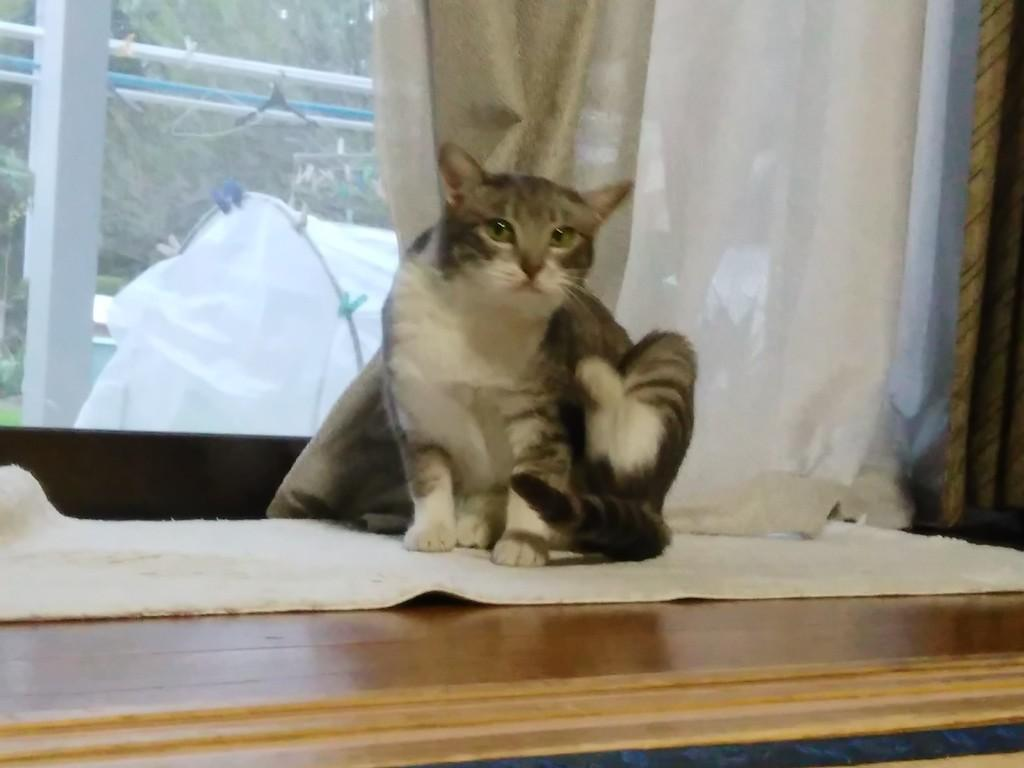What can be seen in the image that allows light to enter the room? There is a window in the image. What type of window treatment is visible in the image? There is a white color curtain in the image. What is on the wooden surface in the image? There is a cloth on a wooden surface in the image. What else can be seen in the image besides the window, curtain, and cloth? There are other objects in the image. What animal is sitting on the cloth in the image? A cat is sitting on the cloth. What arithmetic problem is the cat solving on the cloth in the image? There is no arithmetic problem present in the image; the cat is simply sitting on the cloth. How many dolls are visible in the image? There are no dolls present in the image. 